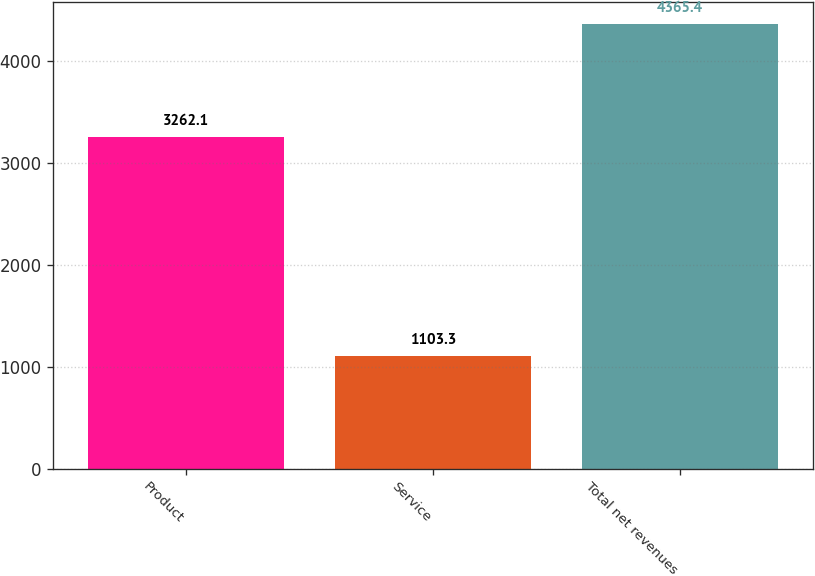Convert chart to OTSL. <chart><loc_0><loc_0><loc_500><loc_500><bar_chart><fcel>Product<fcel>Service<fcel>Total net revenues<nl><fcel>3262.1<fcel>1103.3<fcel>4365.4<nl></chart> 